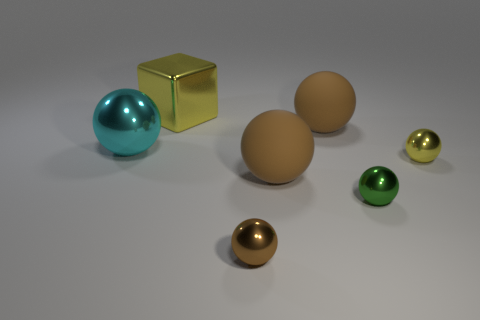Is the metal block the same size as the brown shiny sphere?
Provide a short and direct response. No. The rubber object behind the large matte sphere in front of the yellow shiny sphere is what color?
Make the answer very short. Brown. The large metal sphere has what color?
Offer a very short reply. Cyan. Are there any matte objects of the same color as the big shiny sphere?
Ensure brevity in your answer.  No. There is a small object on the right side of the green ball; does it have the same color as the large cube?
Offer a terse response. Yes. What number of things are either balls that are in front of the cyan sphere or rubber objects?
Your answer should be compact. 5. There is a shiny cube; are there any large things in front of it?
Your answer should be compact. Yes. Is the green object that is in front of the large cyan metal sphere made of the same material as the big yellow thing?
Make the answer very short. Yes. There is a green sphere right of the shiny ball that is on the left side of the big yellow thing; are there any big yellow cubes that are in front of it?
Your response must be concise. No. How many balls are tiny objects or tiny yellow metal objects?
Provide a succinct answer. 3. 